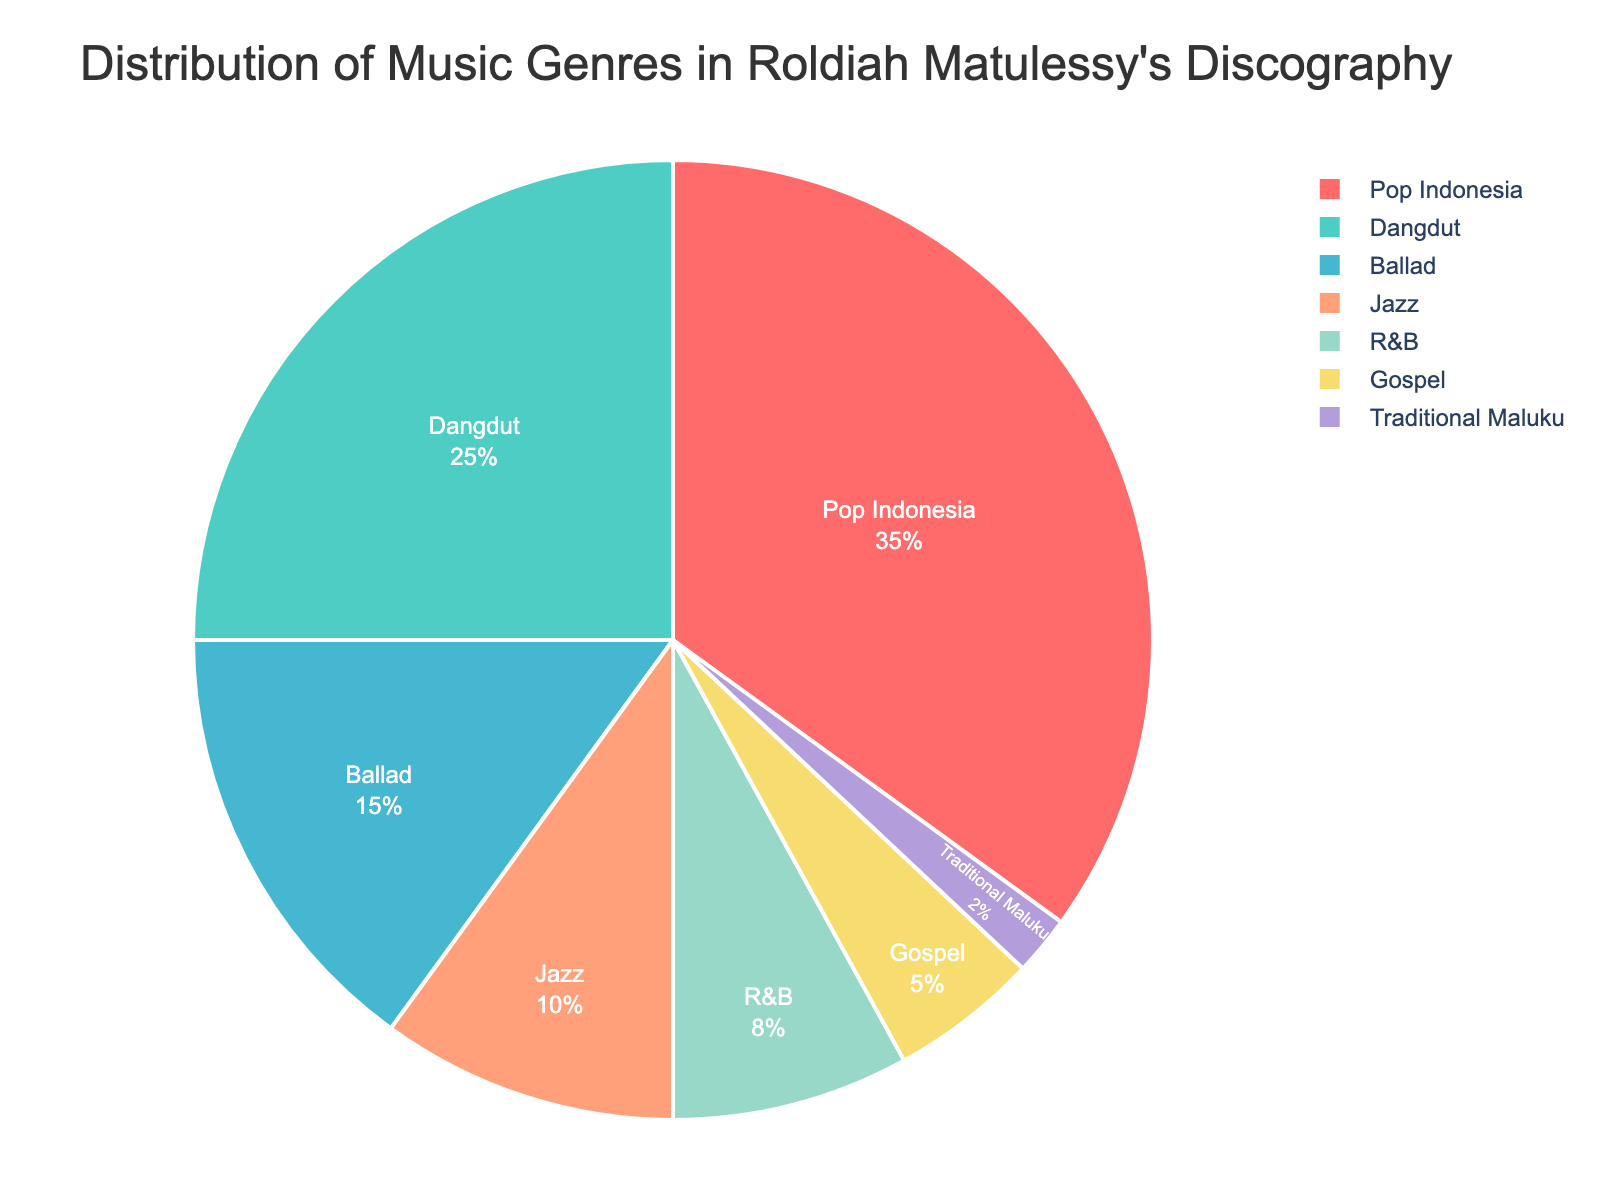What genres constitute more than 50% of Roldiah Matulessy's discography together? First, identify the genres with their corresponding percentages: Pop Indonesia (35%), Dangdut (25%), Ballad (15%), Jazz (10%), R&B (8%), Gospel (5%), Traditional Maluku (2%). Then sum the percentages starting from the highest until you surpass 50%. Pop Indonesia (35%) + Dangdut (25%) = 60%, which is more than 50%. So, Pop Indonesia and Dangdut together constitute more than 50%.
Answer: Pop Indonesia and Dangdut Which genre has the smallest proportion in Roldiah Matulessy's discography? Locate the genre with the smallest percentage in the dataset. Traditional Maluku accounts for 2% of the total, which is the smallest.
Answer: Traditional Maluku What is the percentage difference between Pop Indonesia and Dangdut? Pop Indonesia has 35% and Dangdut has 25%. Subtract the smaller percentage from the larger one: 35% - 25% = 10%.
Answer: 10% How much does the total percentage of Ballad, Jazz, and R&B sum up to? Sum the percentages of Ballad (15%), Jazz (10%), and R&B (8%). 15% + 10% + 8% = 33%.
Answer: 33% Which genre has the closest percentage to Gospel? Compare the percentage of Gospel (5%) with other genres: Traditional Maluku (2%), R&B (8%), Jazz (10%), Ballad (15%), Dangdut (25%), Pop Indonesia (35%). The closest percentage to Gospel (5%) is R&B (8%) with a difference of 3%.
Answer: R&B Between Gospel and Jazz, which genre occupies a larger portion and by how much? Gospel accounts for 5% and Jazz 10%. Jazz is larger. Subtract the smaller percentage (Gospel) from the larger one (Jazz): 10% - 5% = 5%.
Answer: Jazz by 5% What are the combined percentages of the genres that are less than 10% each? Identify the genres with percentages less than 10%: Jazz (10%) is not less than 10%, but R&B (8%), Gospel (5%), and Traditional Maluku (2%) are. Sum their percentages: 8% + 5% + 2% = 15%.
Answer: 15% What is the mean percentage of all the genres combined? Sum all the percentages: 35% + 25% + 15% + 10% + 8% + 5% + 2% = 100%. Since there are 7 genres, divide the total sum by the number of genres: 100% / 7 ≈ 14.29%.
Answer: 14.29% Which two genres together account for exactly 50% of the discography? Test combinations of the genres' percentages. Dangdut (25%) + Ballad (15%) = 40%, Pop Indonesia (35%) + Jazz (10%) = 45%, Pop Indonesia (35%) + Ballad (15%) = 50%. So, Pop Indonesia (35%) and Ballad (15%) together make up exactly 50%.
Answer: Pop Indonesia and Ballad 